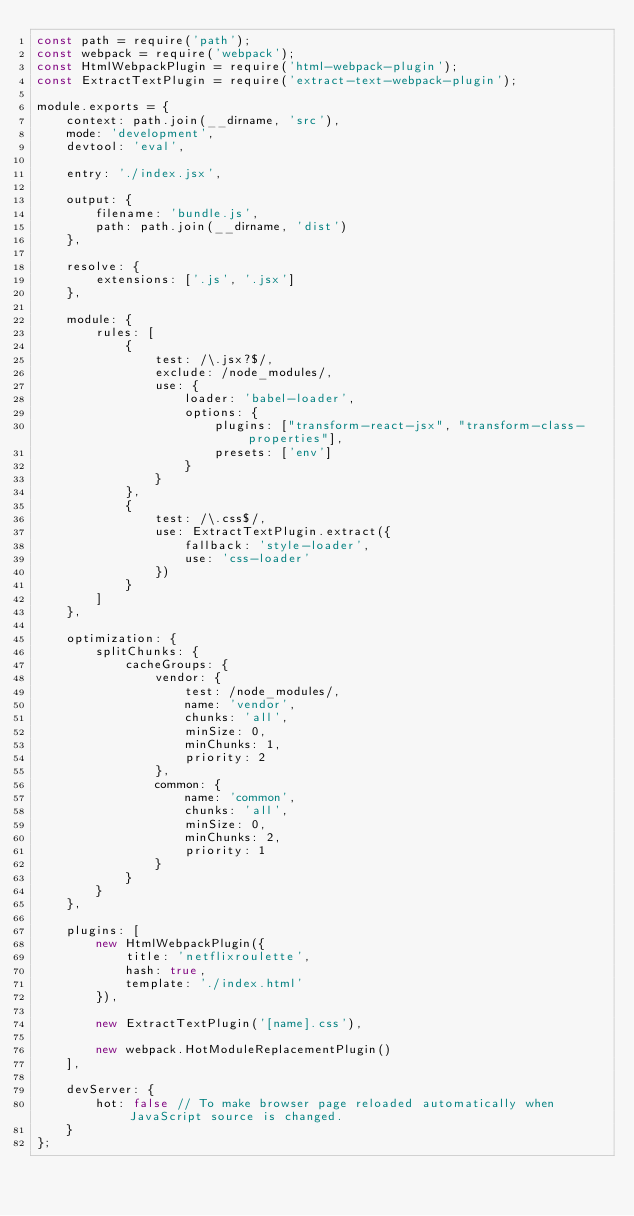<code> <loc_0><loc_0><loc_500><loc_500><_JavaScript_>const path = require('path');
const webpack = require('webpack');
const HtmlWebpackPlugin = require('html-webpack-plugin');
const ExtractTextPlugin = require('extract-text-webpack-plugin');

module.exports = {
    context: path.join(__dirname, 'src'),
    mode: 'development',
    devtool: 'eval',

    entry: './index.jsx',

    output: {
        filename: 'bundle.js',
        path: path.join(__dirname, 'dist')
    },

    resolve: {
        extensions: ['.js', '.jsx']
    },

    module: {
        rules: [
            {
                test: /\.jsx?$/,
                exclude: /node_modules/,
                use: {
                    loader: 'babel-loader',
                    options: {
                        plugins: ["transform-react-jsx", "transform-class-properties"],
                        presets: ['env']
                    }
                }
            },
            {
                test: /\.css$/,
                use: ExtractTextPlugin.extract({
                    fallback: 'style-loader',
                    use: 'css-loader'
                })
            }
        ]
    },

    optimization: {
        splitChunks: {
            cacheGroups: {
                vendor: {
                    test: /node_modules/,
                    name: 'vendor',
                    chunks: 'all',
                    minSize: 0,
                    minChunks: 1,
                    priority: 2
                },
                common: {
                    name: 'common',
                    chunks: 'all',
                    minSize: 0,
                    minChunks: 2,
                    priority: 1
                }
            }
        }
    },

    plugins: [
        new HtmlWebpackPlugin({
            title: 'netflixroulette',
            hash: true,
            template: './index.html'
        }),

        new ExtractTextPlugin('[name].css'),

        new webpack.HotModuleReplacementPlugin()
    ],

    devServer: {
        hot: false // To make browser page reloaded automatically when JavaScript source is changed.
    }
};</code> 